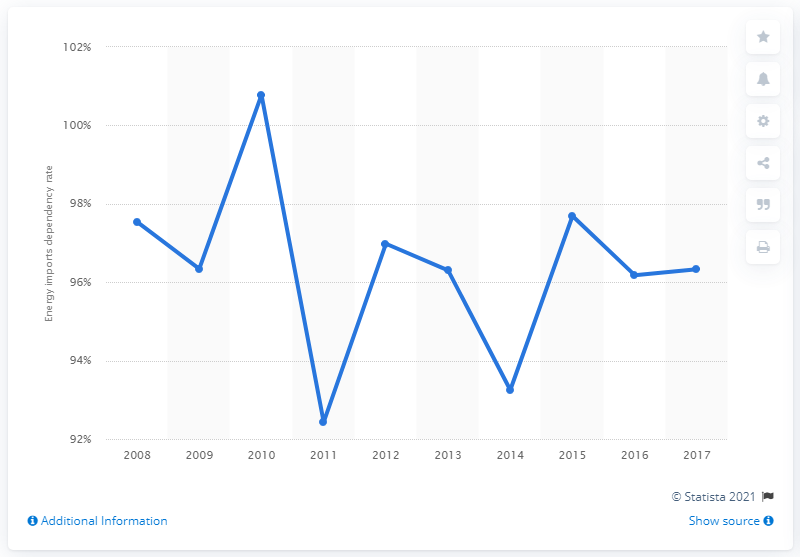Indicate a few pertinent items in this graphic. In 2010, the dependency rate on energy imports was 100.78%. 